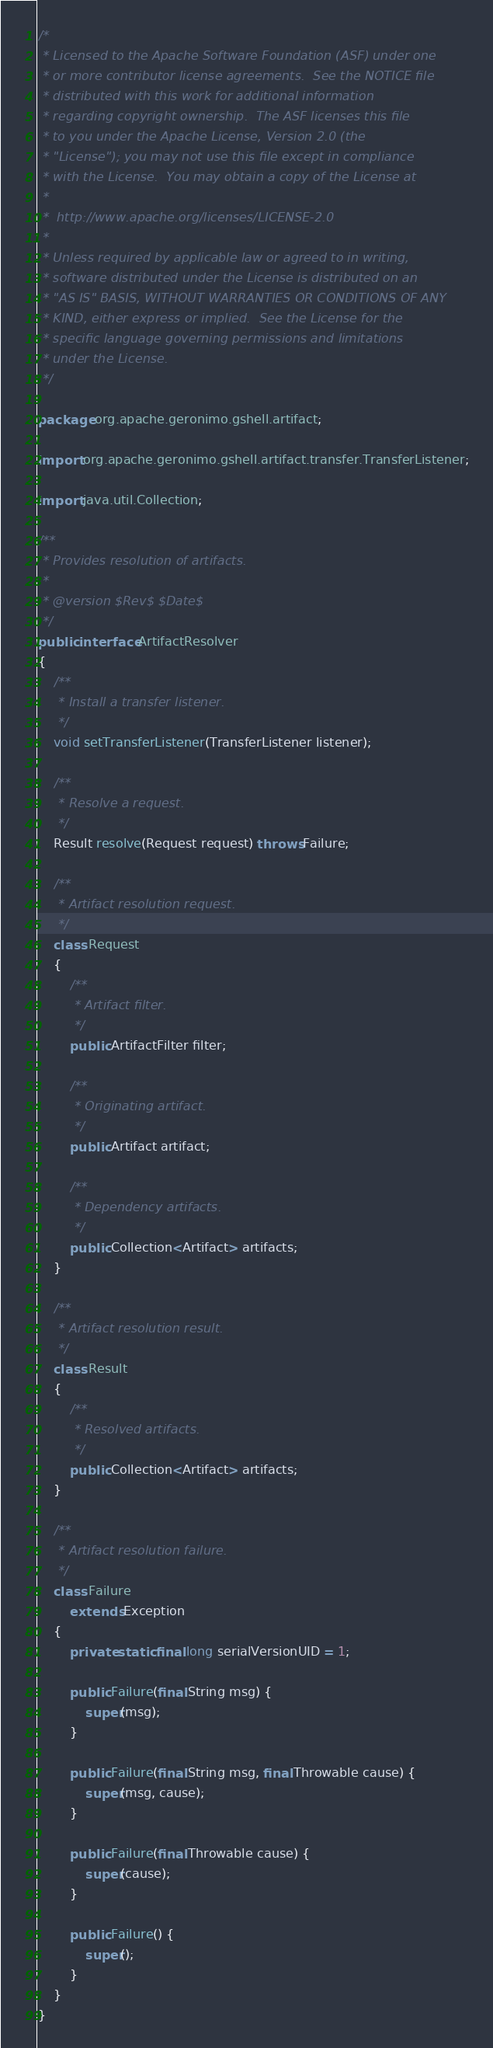<code> <loc_0><loc_0><loc_500><loc_500><_Java_>/*
 * Licensed to the Apache Software Foundation (ASF) under one
 * or more contributor license agreements.  See the NOTICE file
 * distributed with this work for additional information
 * regarding copyright ownership.  The ASF licenses this file
 * to you under the Apache License, Version 2.0 (the
 * "License"); you may not use this file except in compliance
 * with the License.  You may obtain a copy of the License at
 *
 *  http://www.apache.org/licenses/LICENSE-2.0
 *
 * Unless required by applicable law or agreed to in writing,
 * software distributed under the License is distributed on an
 * "AS IS" BASIS, WITHOUT WARRANTIES OR CONDITIONS OF ANY
 * KIND, either express or implied.  See the License for the
 * specific language governing permissions and limitations
 * under the License.
 */

package org.apache.geronimo.gshell.artifact;

import org.apache.geronimo.gshell.artifact.transfer.TransferListener;

import java.util.Collection;

/**
 * Provides resolution of artifacts.
 *
 * @version $Rev$ $Date$
 */
public interface ArtifactResolver
{
    /**
     * Install a transfer listener.
     */
    void setTransferListener(TransferListener listener);

    /**
     * Resolve a request.
     */
    Result resolve(Request request) throws Failure;

    /**
     * Artifact resolution request.
     */
    class Request
    {
        /**
         * Artifact filter.
         */
        public ArtifactFilter filter;

        /**
         * Originating artifact.
         */
        public Artifact artifact;

        /**
         * Dependency artifacts.
         */
        public Collection<Artifact> artifacts;
    }

    /**
     * Artifact resolution result.
     */
    class Result
    {
        /**
         * Resolved artifacts.
         */
        public Collection<Artifact> artifacts;
    }

    /**
     * Artifact resolution failure.
     */
    class Failure
        extends Exception
    {
        private static final long serialVersionUID = 1;

        public Failure(final String msg) {
            super(msg);
        }

        public Failure(final String msg, final Throwable cause) {
            super(msg, cause);
        }

        public Failure(final Throwable cause) {
            super(cause);
        }

        public Failure() {
            super();
        }
    }
}</code> 